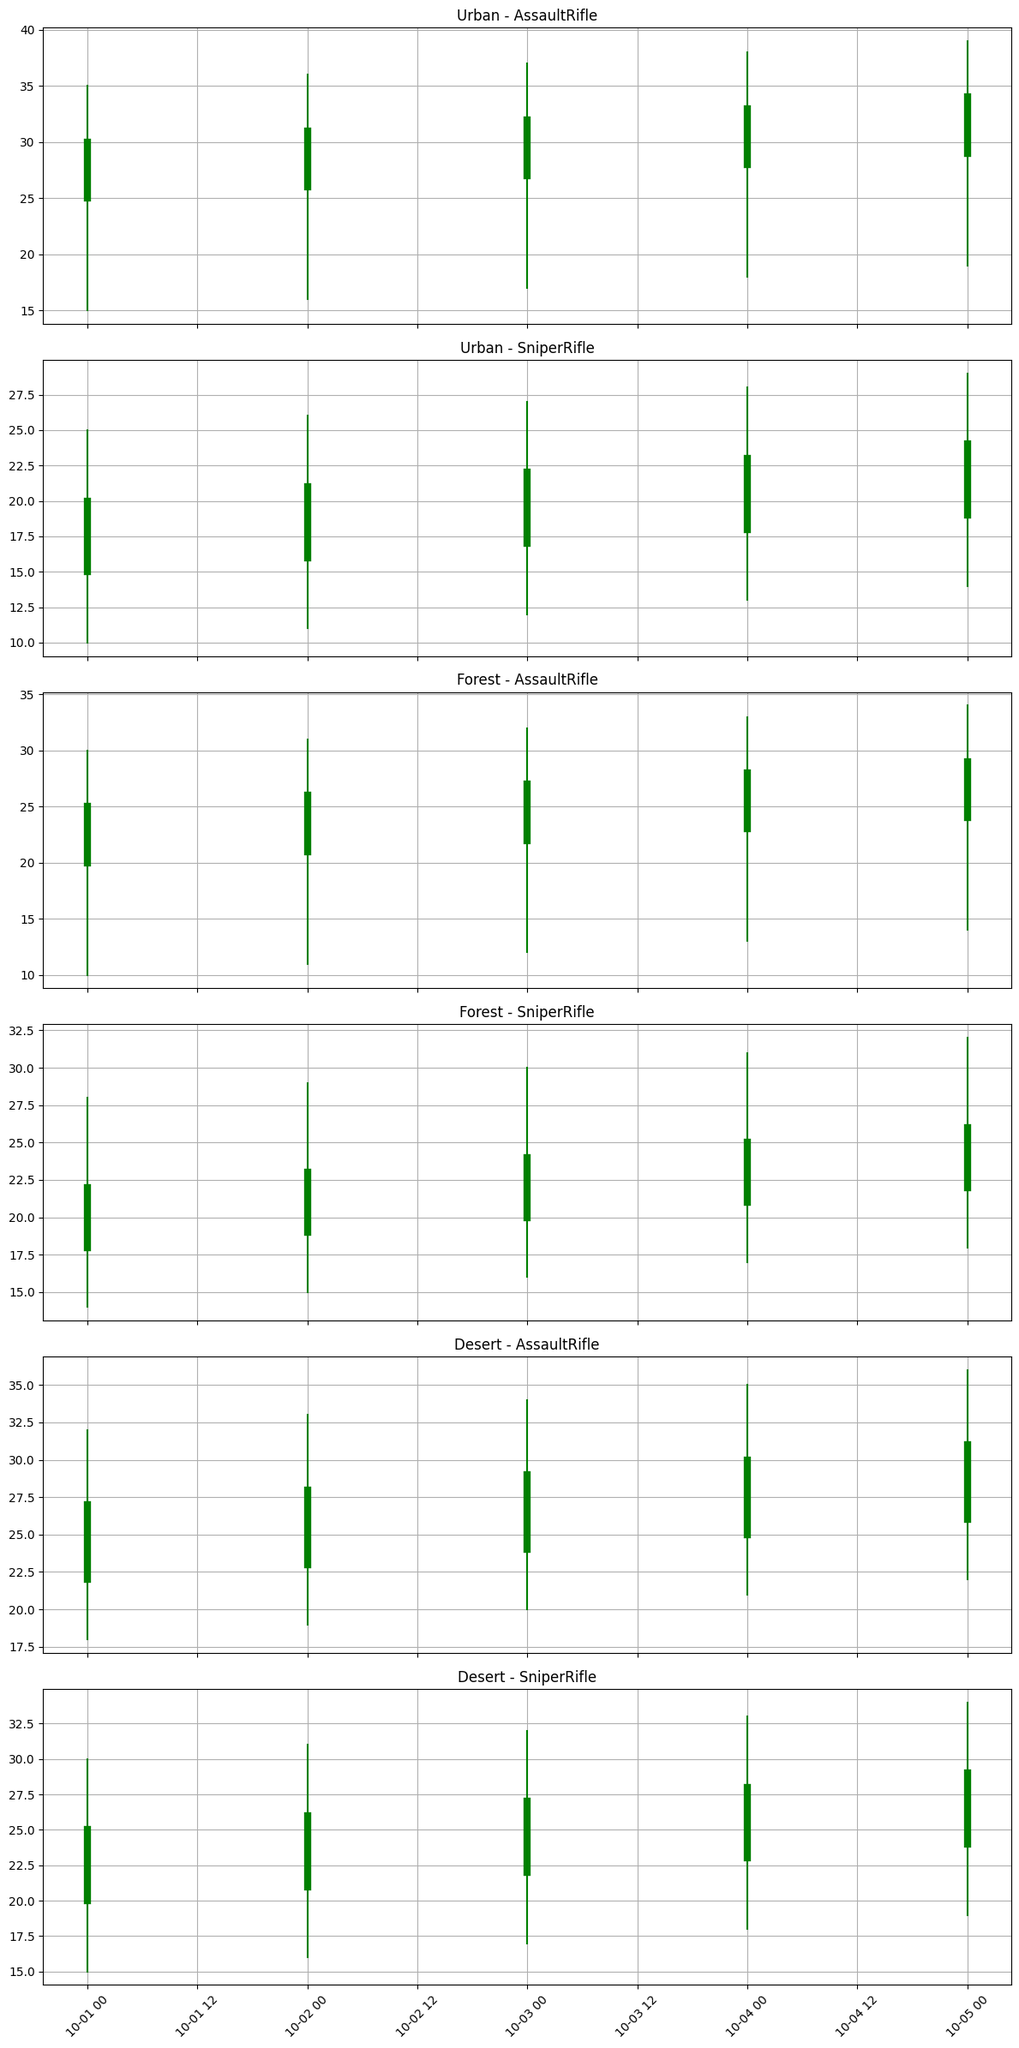Which terrain showed the highest performance for the Assault Rifle on Day 1? On Day 1, for the Assault Rifle, check the closing prices for all terrains: Urban (30), Forest (25), Desert (27). The highest is in Urban (30).
Answer: Urban Which weapon had the lowest performance in the Forest terrain on Day 3? On Day 3, in the Forest terrain, compare the closing prices for Assault Rifle (27) and Sniper Rifle (24). The Sniper Rifle has the lowest closing price (24).
Answer: Sniper Rifle What’s the difference between the opening and closing values of the Sniper Rifle in the Urban terrain on Day 4? On Day 4, for the Sniper Rifle in Urban terrain, the opening value is 18 and the closing value is 23. The difference is 23 - 18 = 5.
Answer: 5 What is the trend for the Assault Rifle’s closing prices in the Desert terrain from Day 1 to Day 5? The closing prices for the Assault Rifle in the Desert terrain are: Day 1 (27), Day 2 (28), Day 3 (29), Day 4 (30), Day 5 (31). There is a consistent increasing trend.
Answer: Increasing Which day showed the biggest variation (difference between high and low) for the Sniper Rifle in the Forest terrain? Calculate the difference between high and low for each day in the Sniper Rifle and Forest combination: Day 1 (28-14 = 14), Day 2 (29-15 = 14), Day 3 (30-16 = 14), Day 4 (31-17 = 14), Day 5 (32-18 = 14). All days show the same variation.
Answer: All days How do the performances of the Sniper Rifle in Urban terrain differ between Day 2 and Day 5 in terms of closing values? Compare the closing values on Day 2 (21) and Day 5 (24) for the Sniper Rifle in Urban terrain. The closing value increased by 24 - 21 = 3.
Answer: Increased by 3 Which weapon has a higher average closing price in the Desert terrain across all days? For the Desert terrain: Assault Rifle closing prices: 27, 28, 29, 30, 31. Sniper Rifle closing prices: 25, 26, 27, 28, 29. The average closing price for Assault Rifle is (27+28+29+30+31)/5 = 29, and for Sniper Rifle is (25+26+27+28+29)/5 = 27. The Assault Rifle has a higher average closing price.
Answer: Assault Rifle On which day did the Assault Rifle perform the best in the Forest terrain? For the Forest terrain across all days, check the closing prices of the Assault Rifle: Day 1 (25), Day 2 (26), Day 3 (27), Day 4 (28), Day 5 (29). The highest closing price is on Day 5 (29).
Answer: Day 5 Is there any case where a weapon's performance closed lower than it opened in the Urban terrain? Check all cases in the Urban terrain: Day 1 (Assault Rifle 30 vs 25, Sniper Rifle 20 vs 15), Day 2 (Assault Rifle 31 vs 26, Sniper Rifle 21 vs 16), Day 3 (Assault Rifle 32 vs 27, Sniper Rifle 22 vs 17), Day 4 (Assault Rifle 33 vs 28, Sniper Rifle 23 vs 18), Day 5 (Assault Rifle 34 vs 29, Sniper Rifle 24 vs 19). In all cases, the closing price is higher than the opening price.
Answer: No What is the overall trend of weapon performance in the Desert terrain across the five days? Examine the closing prices of both Assault Rifle (27, 28, 29, 30, 31) and Sniper Rifle (25, 26, 27, 28, 29) in the Desert terrain from Day 1 to Day 5. Both show an increasing trend.
Answer: Increasing 